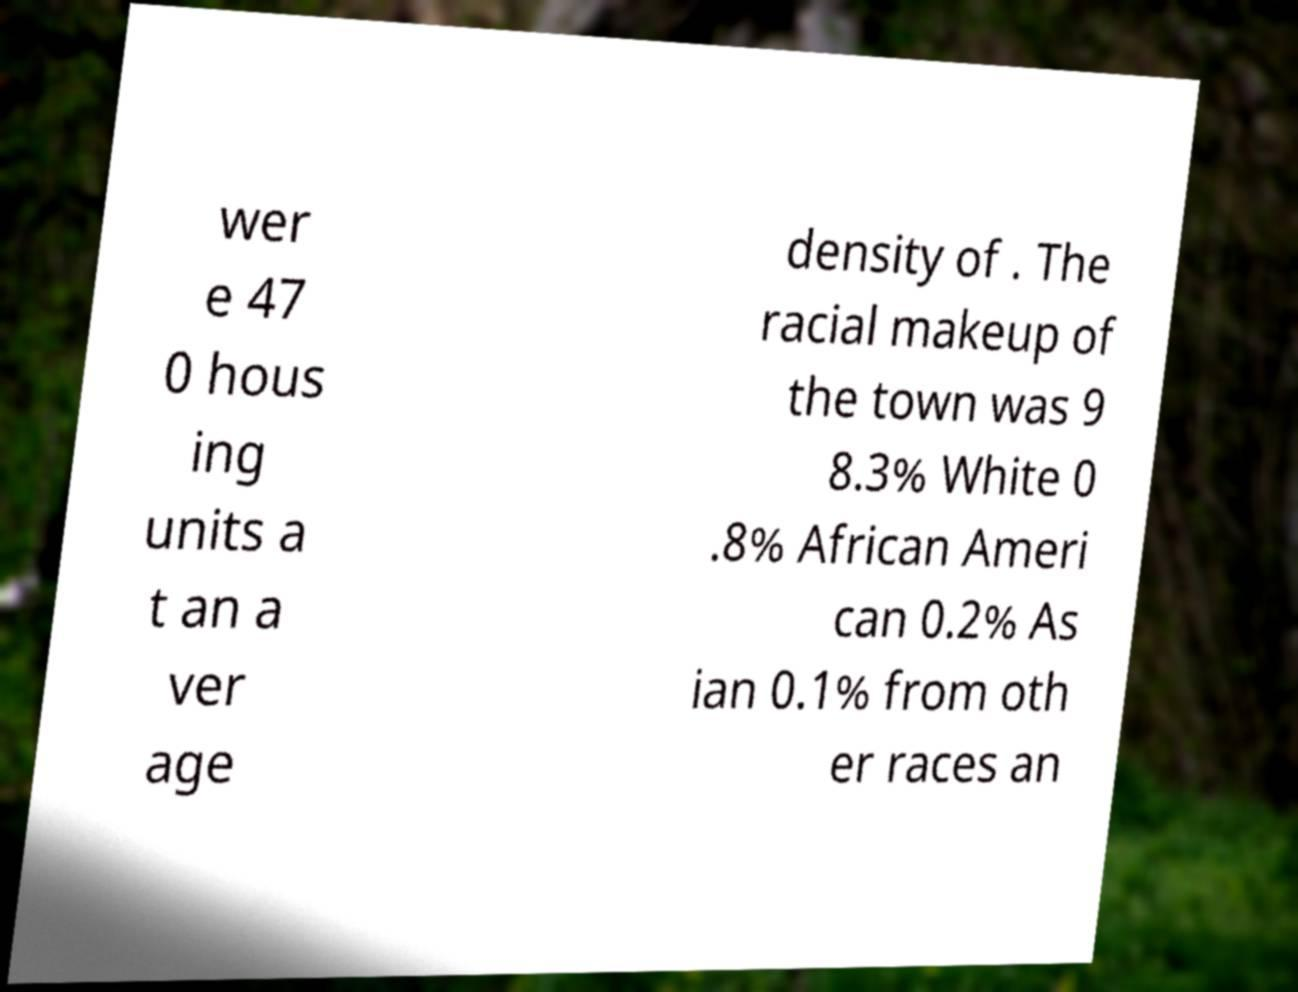Please identify and transcribe the text found in this image. wer e 47 0 hous ing units a t an a ver age density of . The racial makeup of the town was 9 8.3% White 0 .8% African Ameri can 0.2% As ian 0.1% from oth er races an 